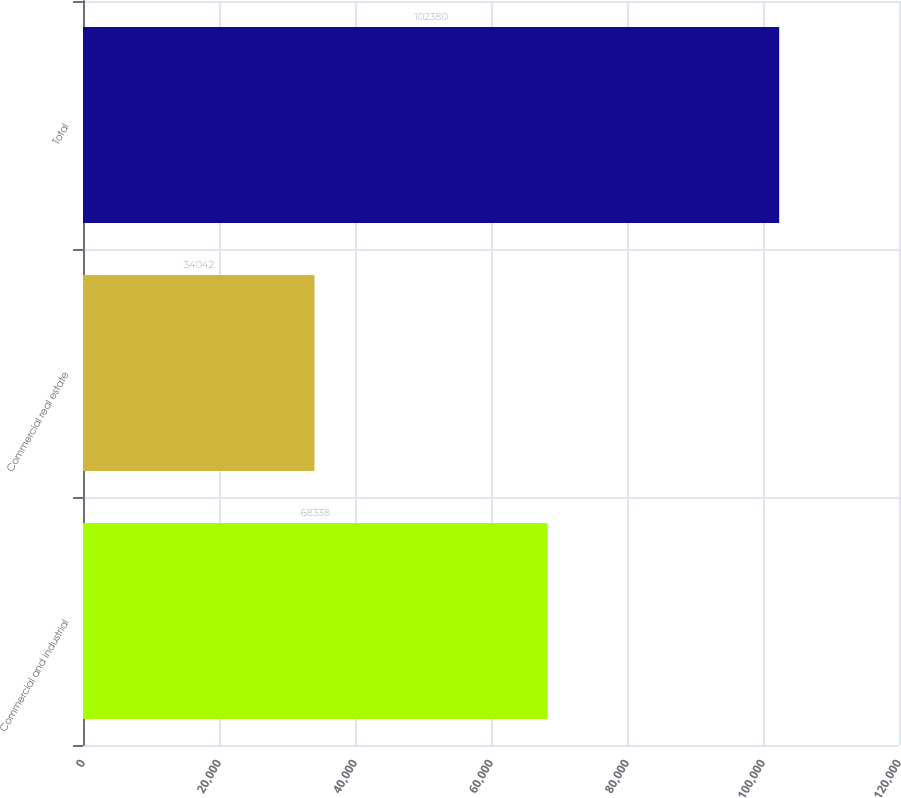Convert chart. <chart><loc_0><loc_0><loc_500><loc_500><bar_chart><fcel>Commercial and industrial<fcel>Commercial real estate<fcel>Total<nl><fcel>68338<fcel>34042<fcel>102380<nl></chart> 